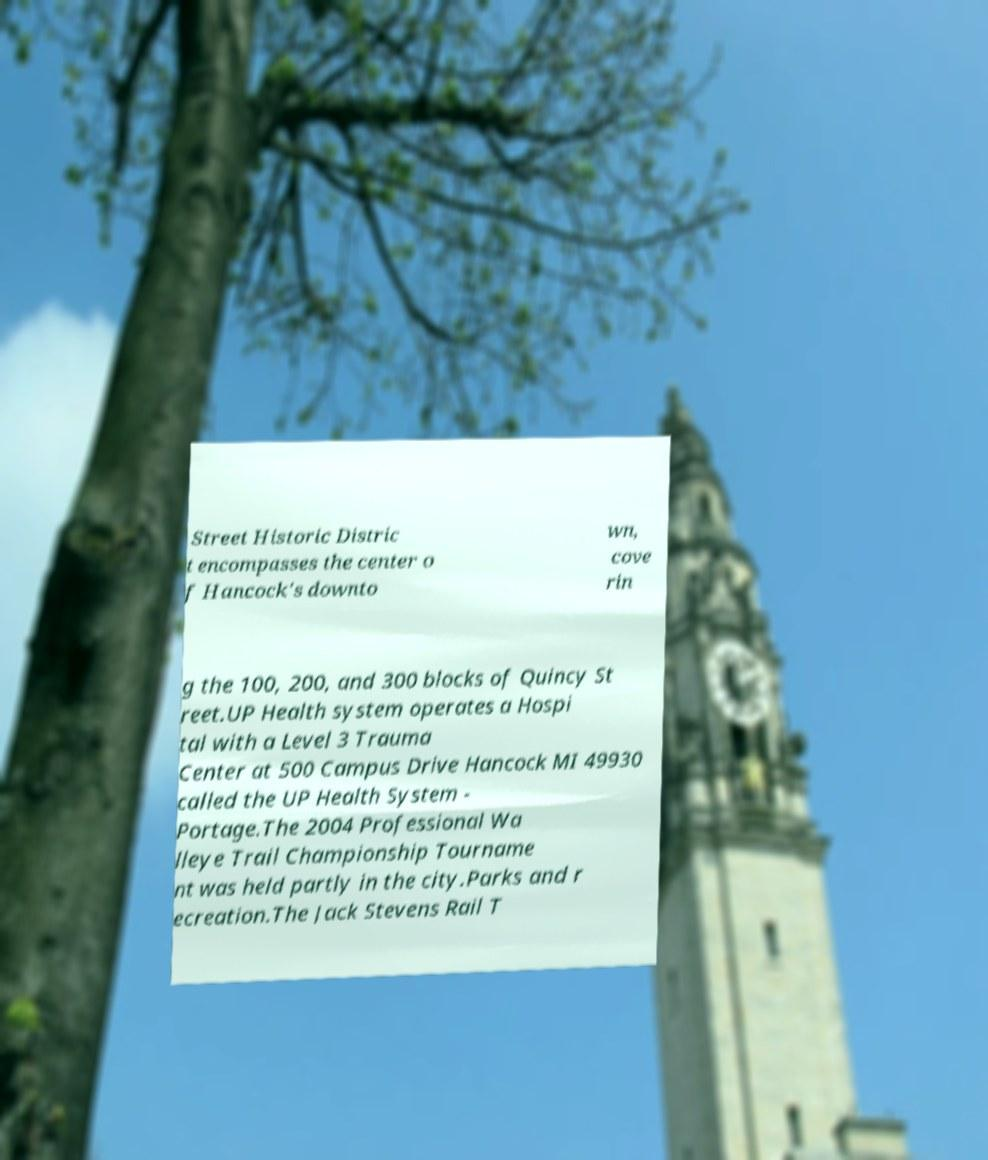Please identify and transcribe the text found in this image. Street Historic Distric t encompasses the center o f Hancock's downto wn, cove rin g the 100, 200, and 300 blocks of Quincy St reet.UP Health system operates a Hospi tal with a Level 3 Trauma Center at 500 Campus Drive Hancock MI 49930 called the UP Health System - Portage.The 2004 Professional Wa lleye Trail Championship Tourname nt was held partly in the city.Parks and r ecreation.The Jack Stevens Rail T 